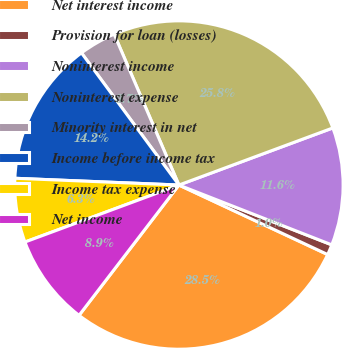<chart> <loc_0><loc_0><loc_500><loc_500><pie_chart><fcel>Net interest income<fcel>Provision for loan (losses)<fcel>Noninterest income<fcel>Noninterest expense<fcel>Minority interest in net<fcel>Income before income tax<fcel>Income tax expense<fcel>Net income<nl><fcel>28.45%<fcel>1.02%<fcel>11.59%<fcel>25.8%<fcel>3.66%<fcel>14.23%<fcel>6.3%<fcel>8.95%<nl></chart> 